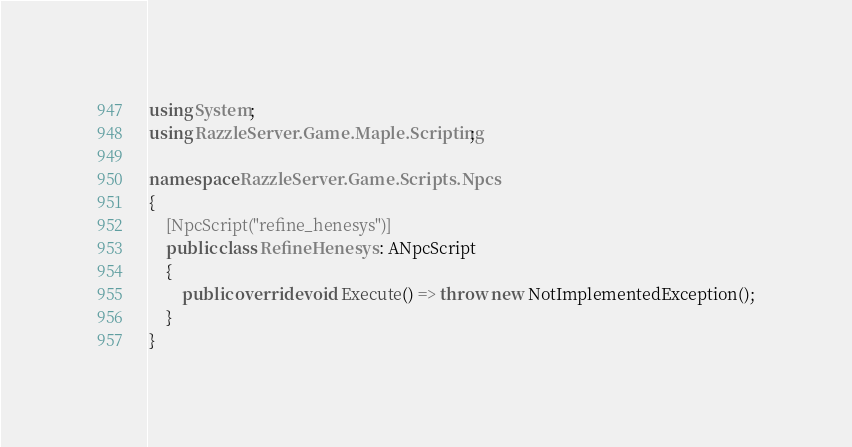<code> <loc_0><loc_0><loc_500><loc_500><_C#_>using System;
using RazzleServer.Game.Maple.Scripting;

namespace RazzleServer.Game.Scripts.Npcs
{
    [NpcScript("refine_henesys")]
    public class RefineHenesys : ANpcScript
    {
        public override void Execute() => throw new NotImplementedException();
    }
}

</code> 